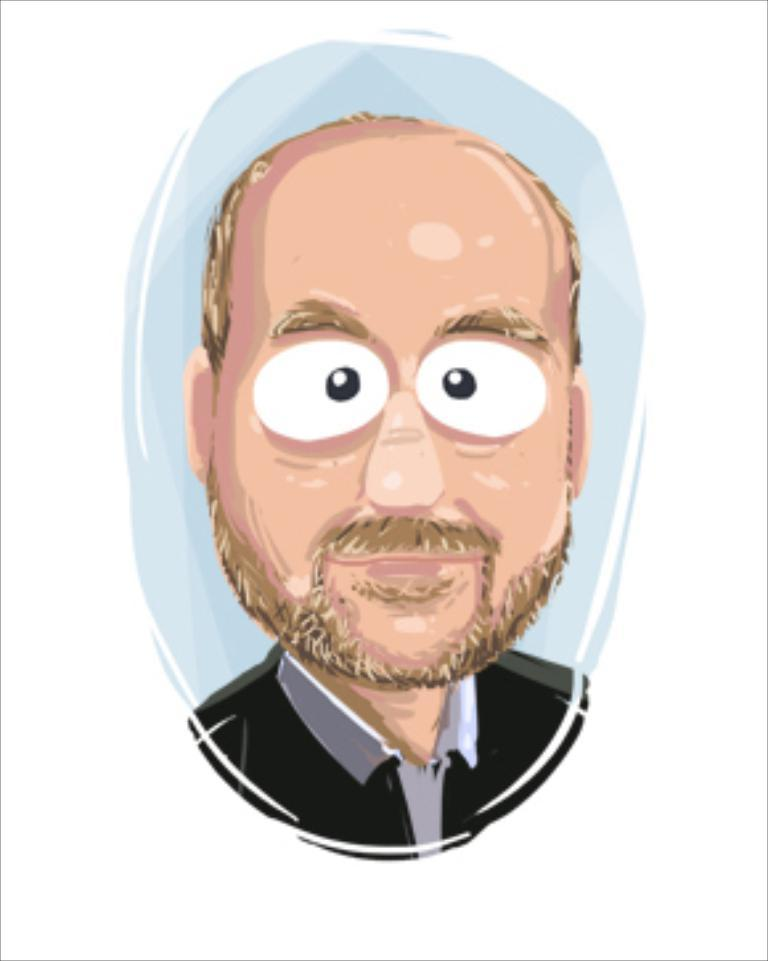What type of image is depicted in the picture? There is a cartoon image of a man in the picture. What color is the background of the image? The background of the image is white. Can you see an orange in the picture? There is no orange present in the image. Is there a kitty playing with the cartoon man in the picture? There is no kitty present in the image. 